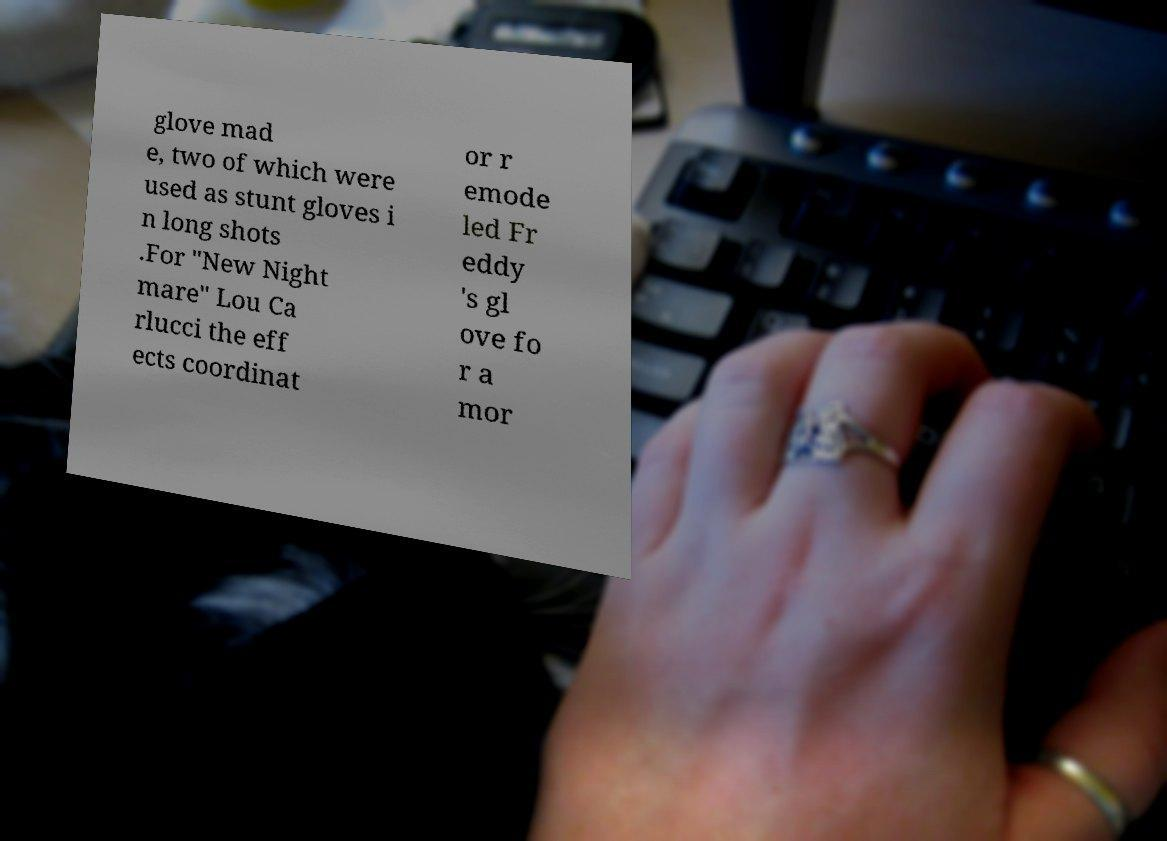Could you extract and type out the text from this image? glove mad e, two of which were used as stunt gloves i n long shots .For "New Night mare" Lou Ca rlucci the eff ects coordinat or r emode led Fr eddy 's gl ove fo r a mor 